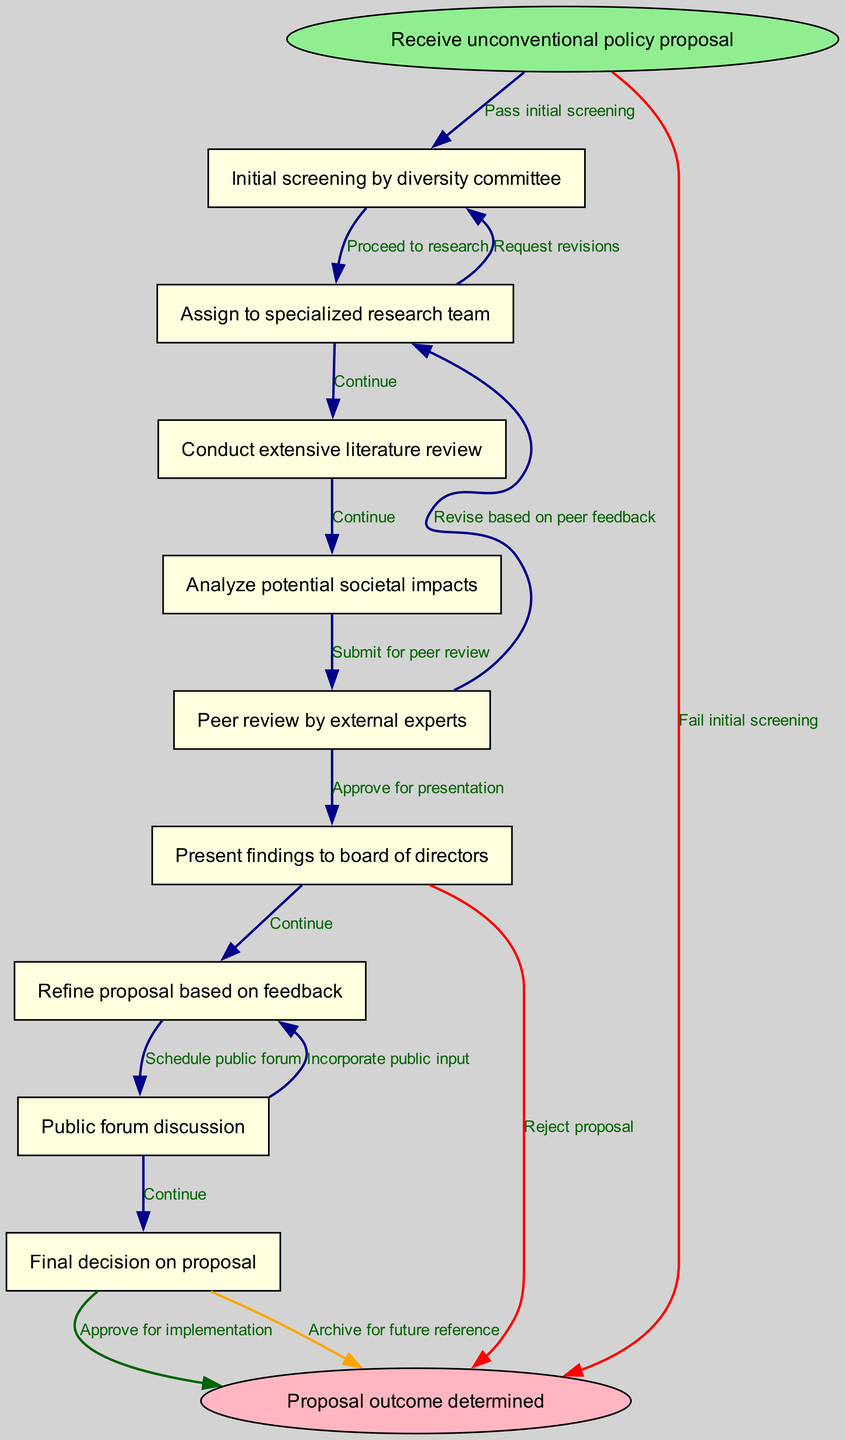What is the first step in the process? The first step in the process, as shown in the diagram, is "Receive unconventional policy proposal" which is the start node.
Answer: Receive unconventional policy proposal How many nodes are there in total? By counting the nodes in the diagram, including the start and end nodes, there are a total of 10 nodes present in the process.
Answer: 10 What is the edge that leads to the end node after peer review? The edge that leads to the end node after peer review is labeled "Reject proposal", indicating that this pathway concludes the review process unfavorably.
Answer: Reject proposal Which committee is involved in the initial screening? The initial screening is conducted by the "diversity committee", as stated in the first node after receiving the proposal.
Answer: diversity committee What happens if the initial screening fails? If the initial screening fails, the proposal is directed to the end node with the edge labeled "Fail initial screening", which signifies the end of this process without further consideration.
Answer: Fail initial screening What process follows the presentation of findings to the board? After presenting findings to the board, the next step is to "Refine proposal based on feedback", which indicates that feedback is integrated into the proposal.
Answer: Refine proposal based on feedback What action occurs after public forum discussion? After the public forum discussion, the proposal might either lead to an "Approve for implementation" edge or "Archive for future reference", depicting the possible outcomes from public input.
Answer: Approve for implementation What does the diagram imply about proposals that pass initial screening? Proposals that pass the initial screening will "Assign to specialized research team", indicating a positive progression into more thorough evaluation.
Answer: Assign to specialized research team Which step includes input from external experts? The step that includes input from external experts is "Peer review by external experts", where independent evaluations are conducted on the proposal.
Answer: Peer review by external experts 